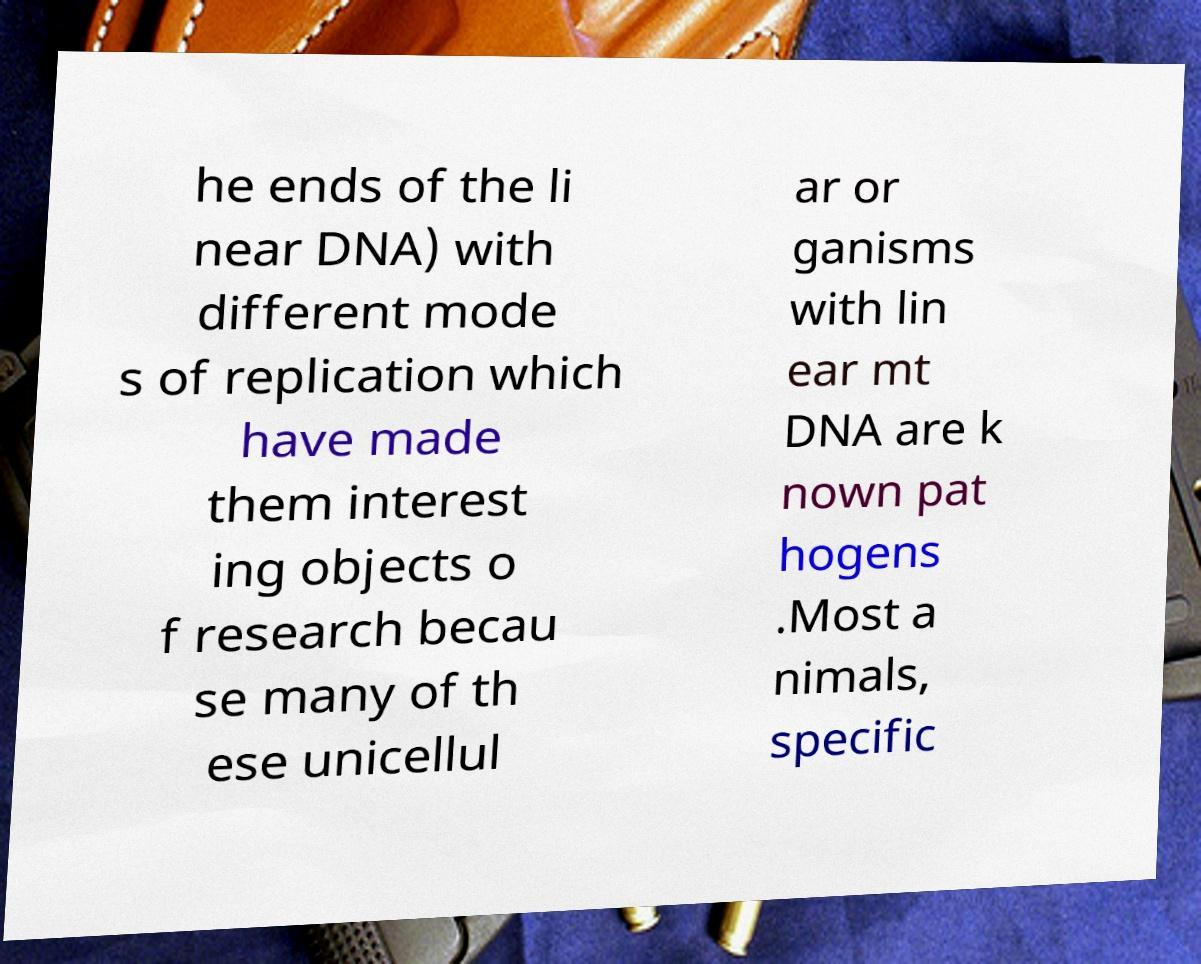I need the written content from this picture converted into text. Can you do that? he ends of the li near DNA) with different mode s of replication which have made them interest ing objects o f research becau se many of th ese unicellul ar or ganisms with lin ear mt DNA are k nown pat hogens .Most a nimals, specific 